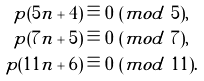Convert formula to latex. <formula><loc_0><loc_0><loc_500><loc_500>p ( 5 n + 4 ) & \equiv 0 \ ( m o d \ 5 ) , \\ p ( 7 n + 5 ) & \equiv 0 \ ( m o d \ 7 ) , \\ p ( 1 1 n + 6 ) & \equiv 0 \ ( m o d \ 1 1 ) .</formula> 